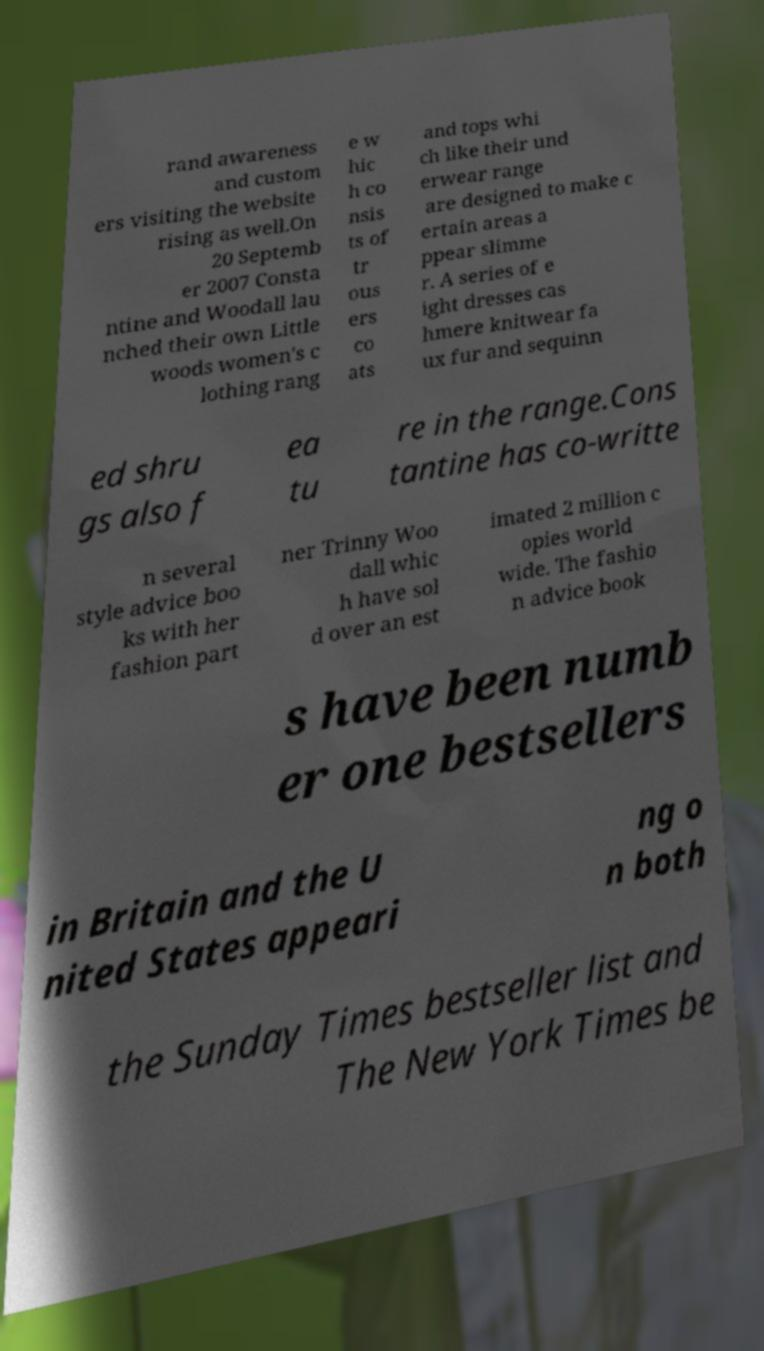Can you accurately transcribe the text from the provided image for me? rand awareness and custom ers visiting the website rising as well.On 20 Septemb er 2007 Consta ntine and Woodall lau nched their own Little woods women's c lothing rang e w hic h co nsis ts of tr ous ers co ats and tops whi ch like their und erwear range are designed to make c ertain areas a ppear slimme r. A series of e ight dresses cas hmere knitwear fa ux fur and sequinn ed shru gs also f ea tu re in the range.Cons tantine has co-writte n several style advice boo ks with her fashion part ner Trinny Woo dall whic h have sol d over an est imated 2 million c opies world wide. The fashio n advice book s have been numb er one bestsellers in Britain and the U nited States appeari ng o n both the Sunday Times bestseller list and The New York Times be 